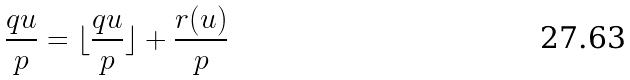<formula> <loc_0><loc_0><loc_500><loc_500>\frac { q u } { p } = \lfloor \frac { q u } { p } \rfloor + \frac { r ( u ) } { p }</formula> 